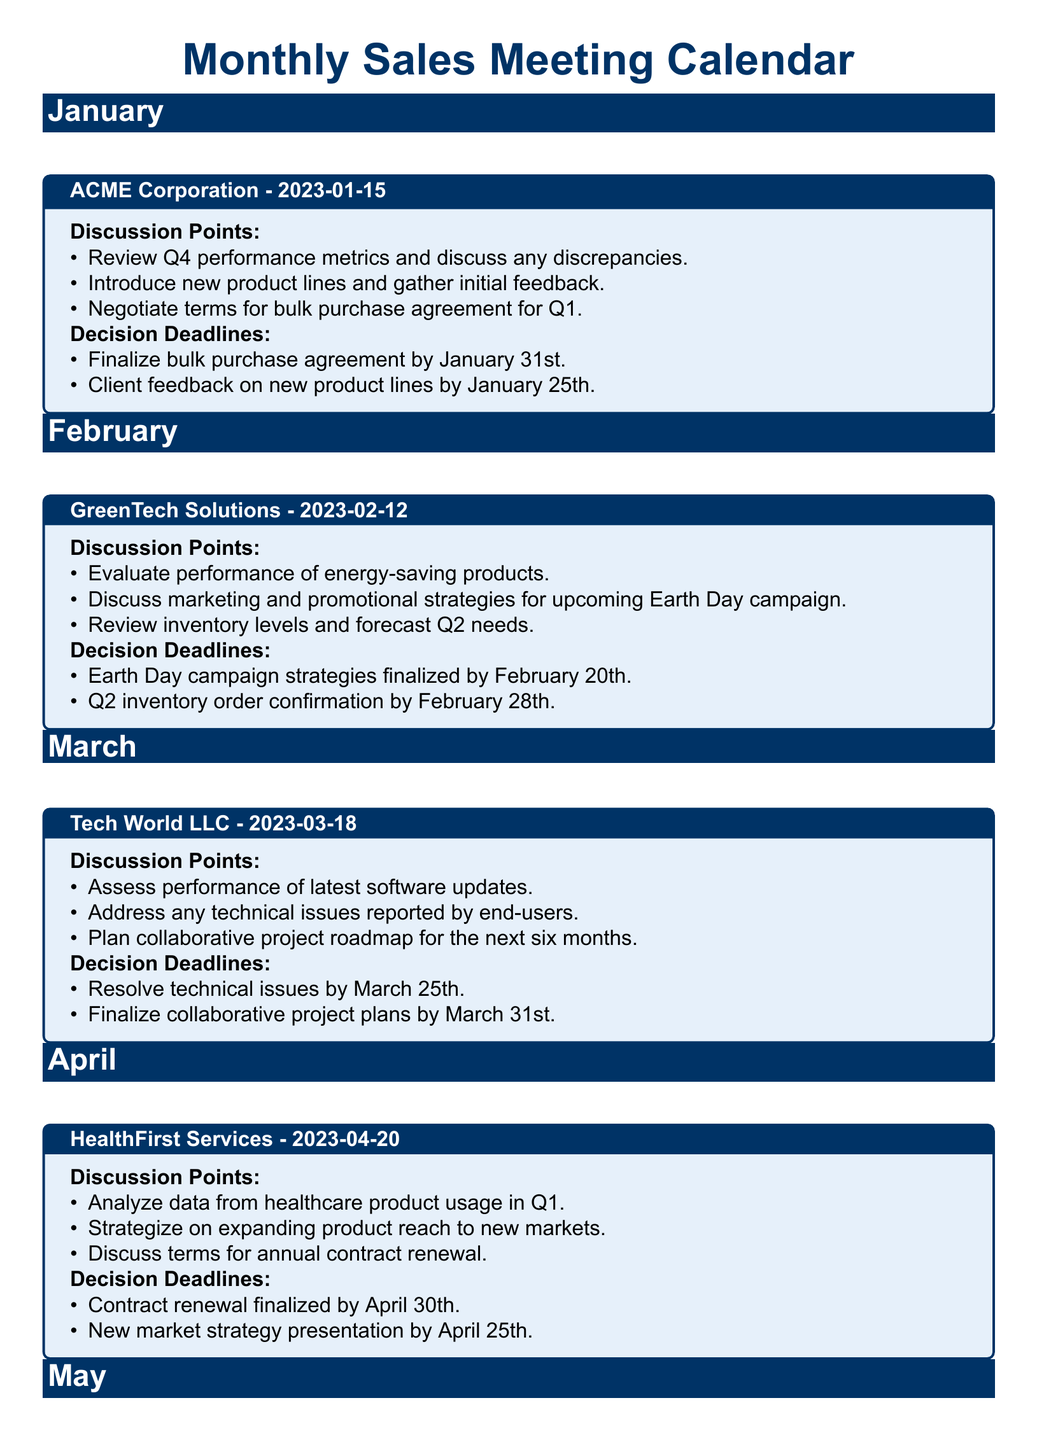What is the date of the meeting with ACME Corporation? The meeting with ACME Corporation is scheduled for January 15, 2023.
Answer: January 15, 2023 What are the decision deadlines discussed for GreenTech Solutions? The decision deadlines for GreenTech Solutions are: Earth Day campaign strategies finalized by February 20th and Q2 inventory order confirmation by February 28th.
Answer: February 20th, February 28th What product lines will be introduced in January's meeting? The discussion for January includes the introduction of new product lines and gathering initial feedback.
Answer: New product lines When is the contract renewal for HealthFirst Services due? The contract renewal for HealthFirst Services must be finalized by April 30th.
Answer: April 30th How many discussion points are listed for the meeting in March? There are three discussion points listed for the meeting with Tech World LLC in March.
Answer: Three What is the focus of the discussion points for Urban Retailers Inc.? The discussion points focus on reviewing performance metrics, planning promotional activities, and discussing a loyalty program.
Answer: Performance metrics, promotional activities, loyalty program What is the proposed timeline for the decision on the loyalty program? The decision on the loyalty program is to be made by May 28th.
Answer: May 28th Which client meeting is scheduled for April? The meeting scheduled for April is with HealthFirst Services.
Answer: HealthFirst Services 